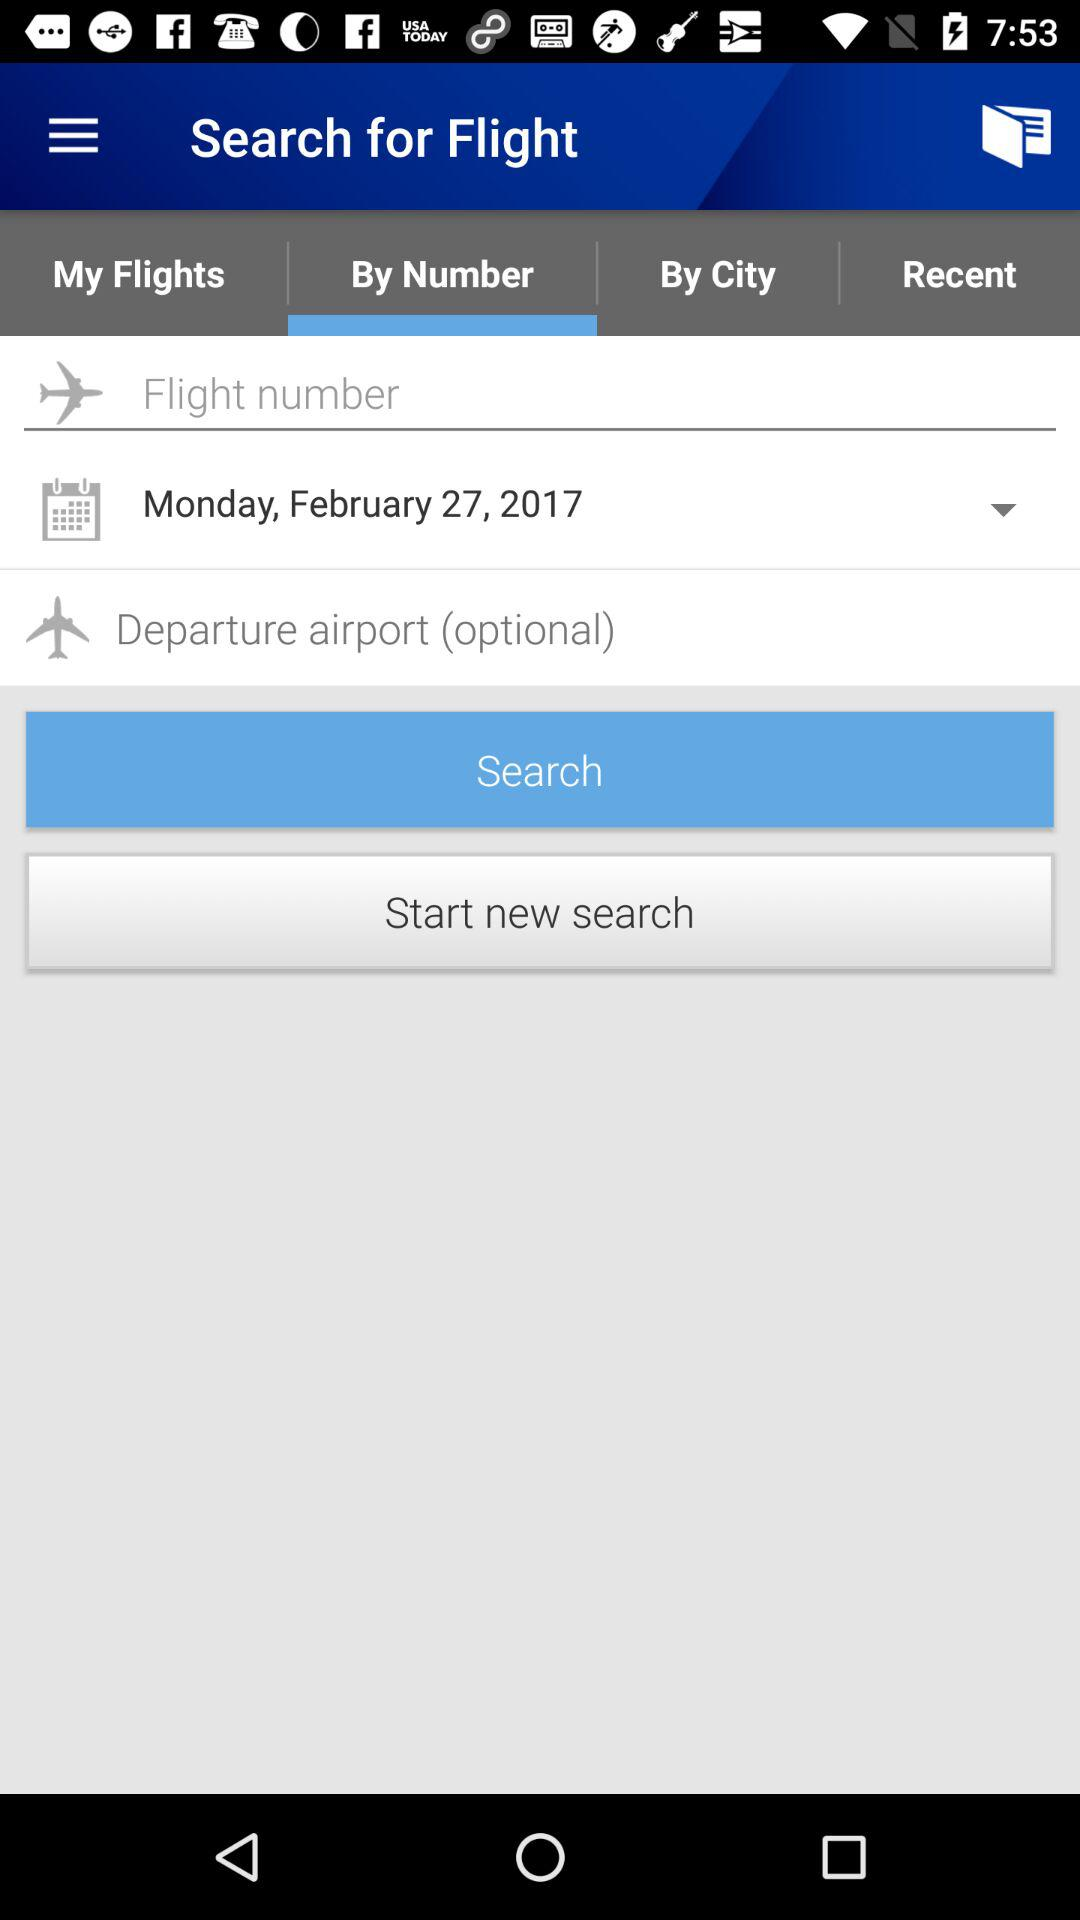Which day falls on February 27, 2017? The day is Monday. 